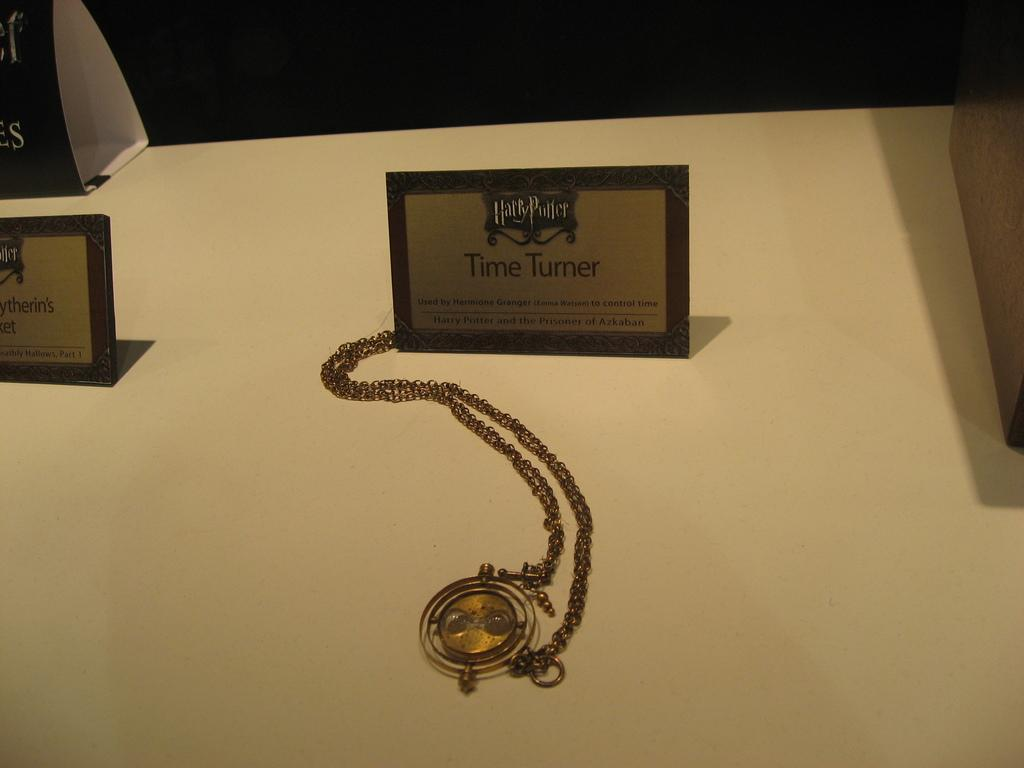<image>
Summarize the visual content of the image. A watch that is under the Time Turner name plate. 